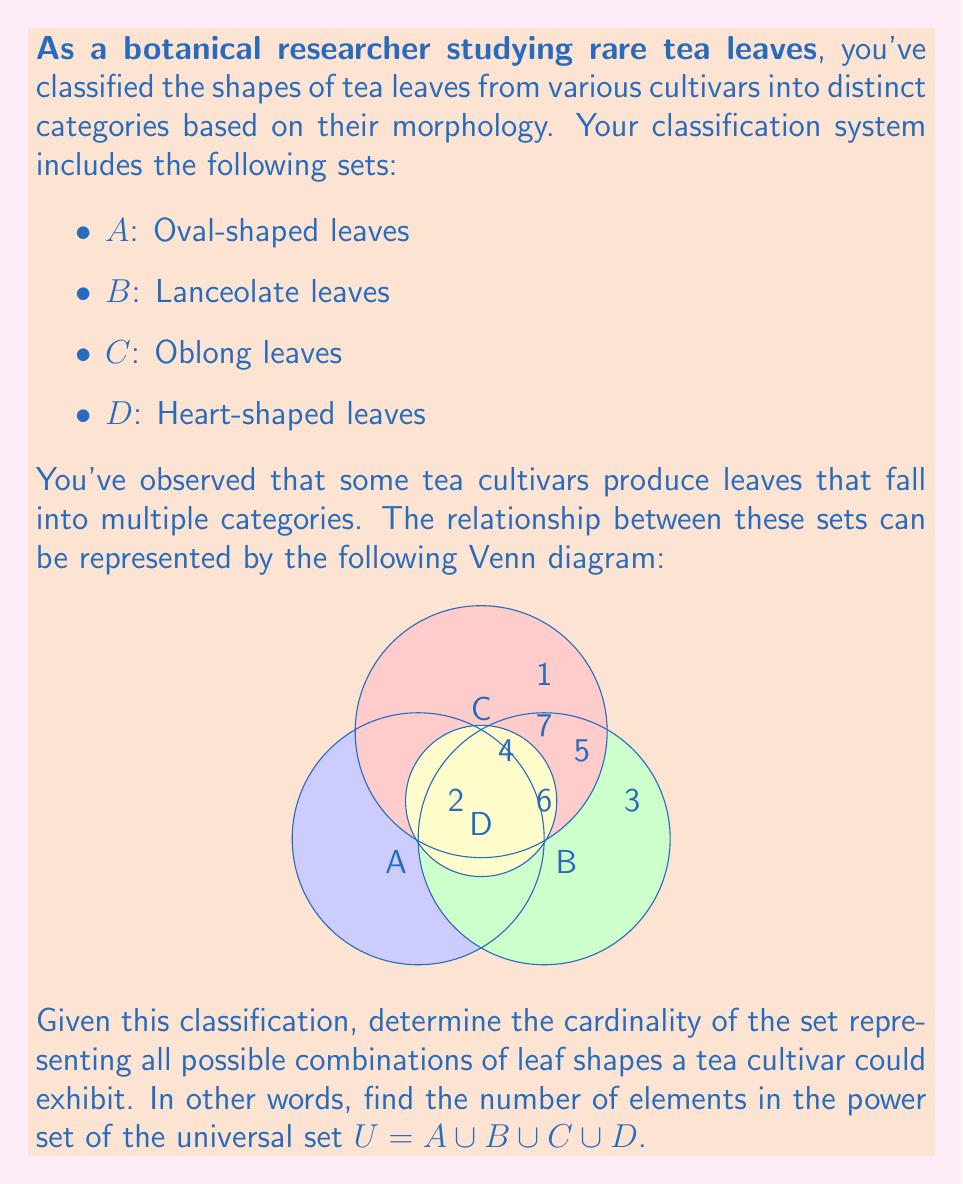Teach me how to tackle this problem. To solve this problem, we need to follow these steps:

1) First, we need to understand what the power set is. The power set of a set S is the set of all subsets of S, including the empty set and S itself.

2) The cardinality of the power set of a set with n elements is $2^n$.

3) In this case, we need to find the number of distinct regions in the Venn diagram, as each region represents a unique combination of leaf shapes.

4) From the Venn diagram, we can count the distinct regions:
   - 4 regions where leaves have only one shape (2, 3, 1, and the part of D not overlapping others)
   - 5 regions where leaves have two shapes (the overlaps between A&B, A&C, B&C, A&D, B&D)
   - 2 regions where leaves have three shapes (the triple overlaps of A&B&D and A&C&D)
   - 1 region where leaves have all four shapes (the center where all sets overlap)
   - 1 region representing tea plants with none of these leaf shapes (the area outside all circles)

5) In total, we have 4 + 5 + 2 + 1 + 1 = 13 distinct regions.

6) Therefore, the universal set U has 13 elements.

7) The cardinality of the power set of U is thus $2^{13}$.
Answer: $2^{13} = 8192$ 